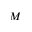Convert formula to latex. <formula><loc_0><loc_0><loc_500><loc_500>M</formula> 